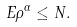Convert formula to latex. <formula><loc_0><loc_0><loc_500><loc_500>E \rho ^ { \alpha } \leq N .</formula> 